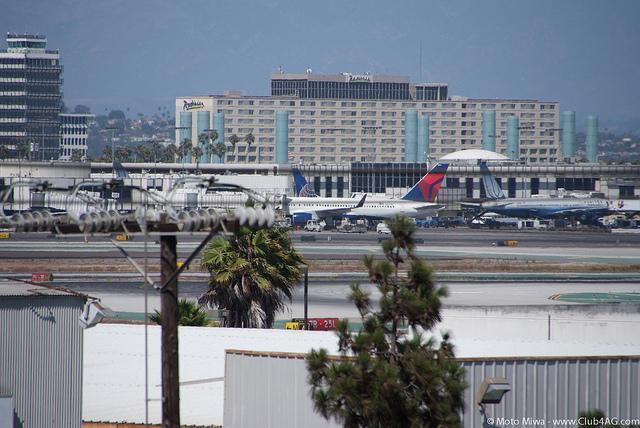How many airplanes are visible?
Give a very brief answer. 2. How many different kinds of pizzas are there?
Give a very brief answer. 0. 